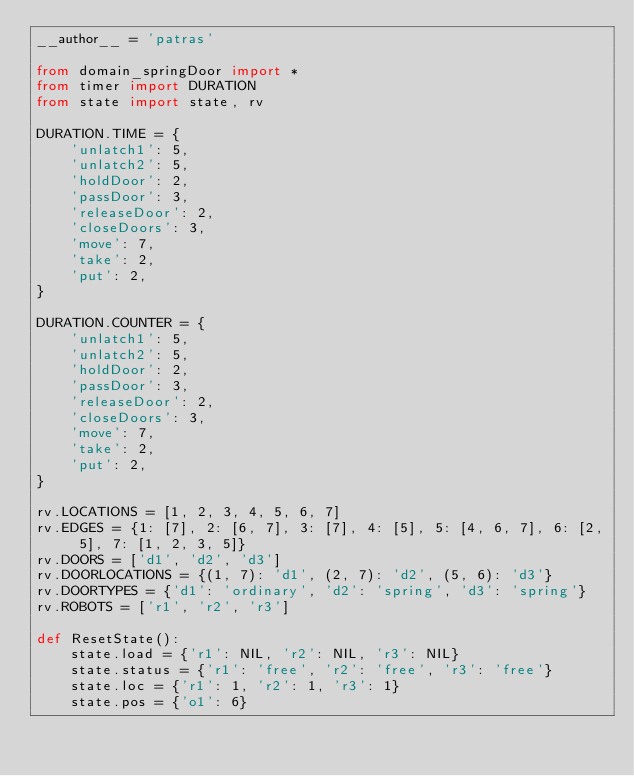<code> <loc_0><loc_0><loc_500><loc_500><_Python_>__author__ = 'patras'

from domain_springDoor import *
from timer import DURATION
from state import state, rv

DURATION.TIME = {
    'unlatch1': 5,
    'unlatch2': 5,
    'holdDoor': 2,
    'passDoor': 3,
    'releaseDoor': 2,
    'closeDoors': 3,
    'move': 7,
    'take': 2,
    'put': 2,
}

DURATION.COUNTER = {
    'unlatch1': 5,
    'unlatch2': 5,
    'holdDoor': 2,
    'passDoor': 3,
    'releaseDoor': 2,
    'closeDoors': 3,
    'move': 7,
    'take': 2,
    'put': 2,
}

rv.LOCATIONS = [1, 2, 3, 4, 5, 6, 7]
rv.EDGES = {1: [7], 2: [6, 7], 3: [7], 4: [5], 5: [4, 6, 7], 6: [2, 5], 7: [1, 2, 3, 5]}
rv.DOORS = ['d1', 'd2', 'd3']
rv.DOORLOCATIONS = {(1, 7): 'd1', (2, 7): 'd2', (5, 6): 'd3'}
rv.DOORTYPES = {'d1': 'ordinary', 'd2': 'spring', 'd3': 'spring'}
rv.ROBOTS = ['r1', 'r2', 'r3']

def ResetState():
    state.load = {'r1': NIL, 'r2': NIL, 'r3': NIL}
    state.status = {'r1': 'free', 'r2': 'free', 'r3': 'free'}
    state.loc = {'r1': 1, 'r2': 1, 'r3': 1}
    state.pos = {'o1': 6}</code> 